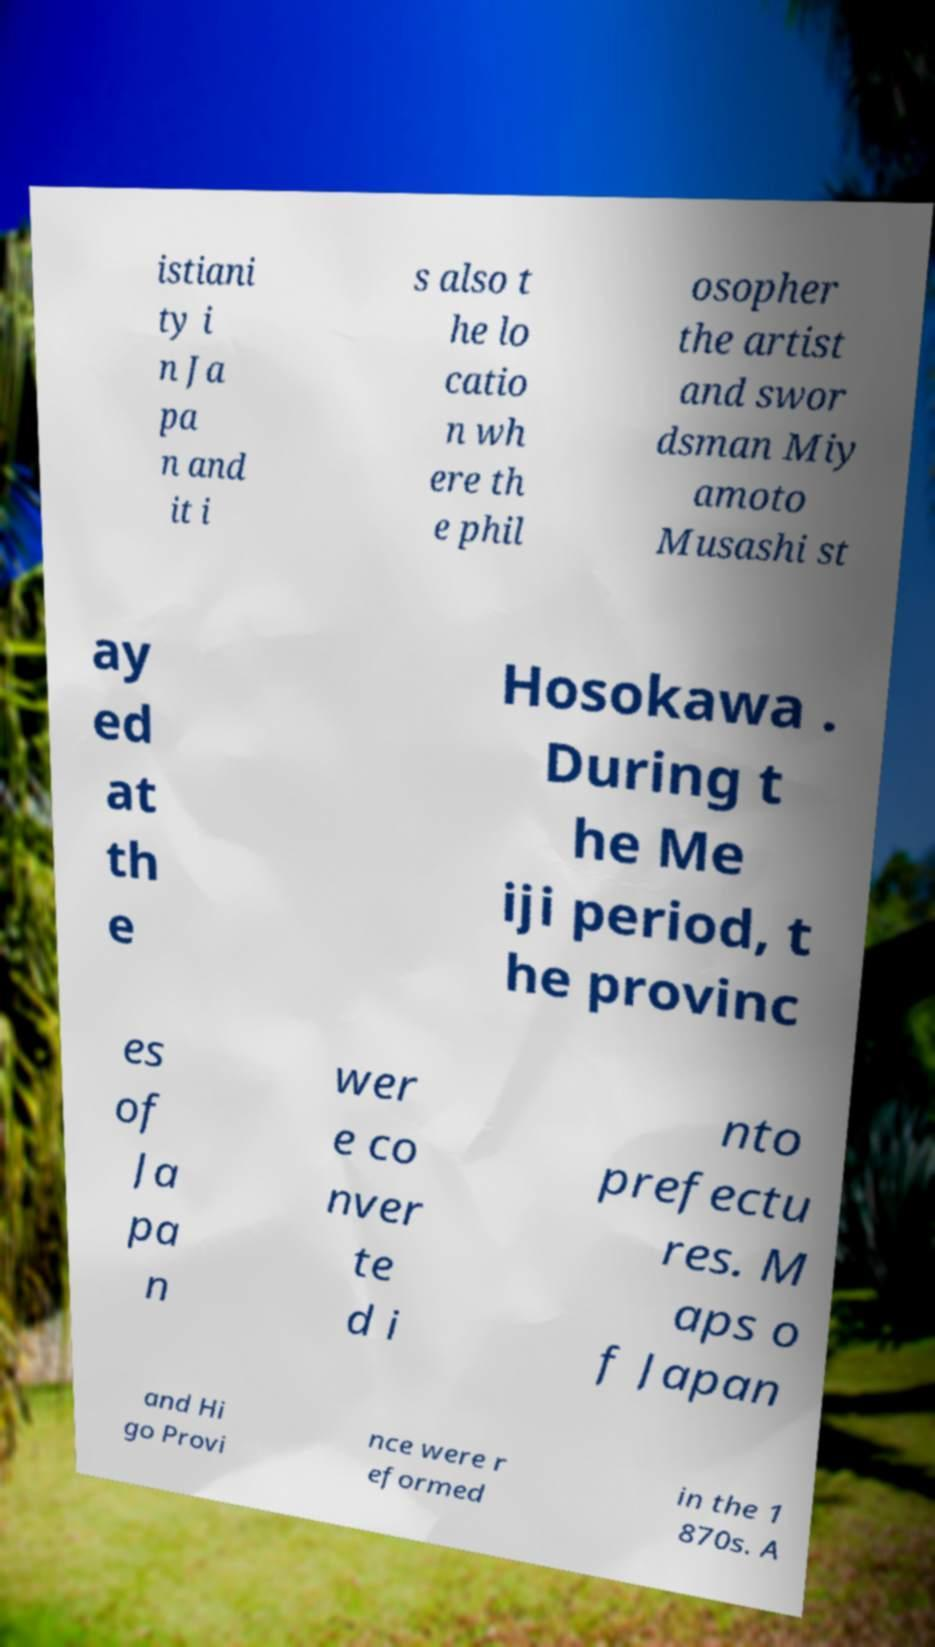Can you read and provide the text displayed in the image?This photo seems to have some interesting text. Can you extract and type it out for me? istiani ty i n Ja pa n and it i s also t he lo catio n wh ere th e phil osopher the artist and swor dsman Miy amoto Musashi st ay ed at th e Hosokawa . During t he Me iji period, t he provinc es of Ja pa n wer e co nver te d i nto prefectu res. M aps o f Japan and Hi go Provi nce were r eformed in the 1 870s. A 